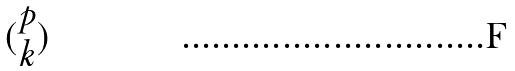<formula> <loc_0><loc_0><loc_500><loc_500>( \begin{matrix} p \\ k \end{matrix} )</formula> 